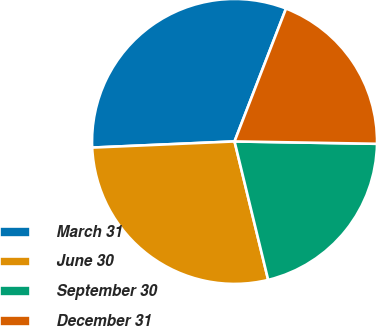Convert chart to OTSL. <chart><loc_0><loc_0><loc_500><loc_500><pie_chart><fcel>March 31<fcel>June 30<fcel>September 30<fcel>December 31<nl><fcel>31.57%<fcel>28.1%<fcel>20.94%<fcel>19.38%<nl></chart> 